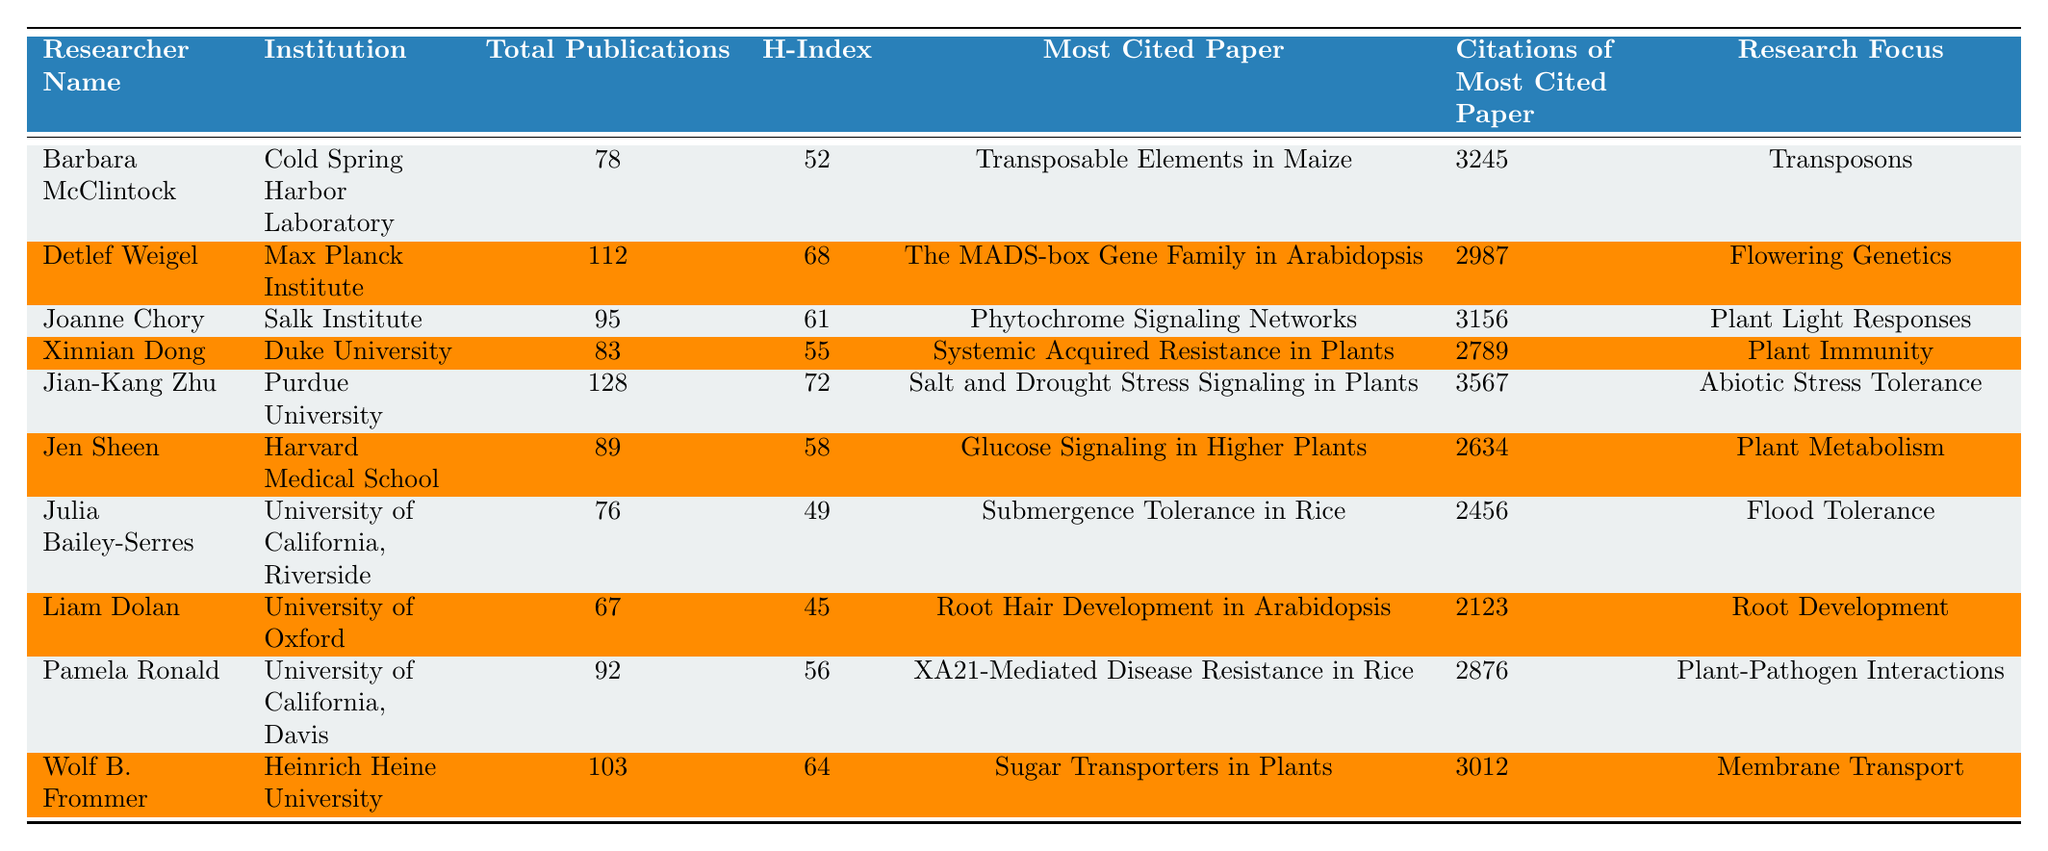What is the total number of publications by Jian-Kang Zhu? According to the table, Jian-Kang Zhu has 128 total publications listed in the "Total Publications" column.
Answer: 128 Which researcher has the highest H-Index? By scanning the H-Index values in the table, Jian-Kang Zhu has the highest H-Index at 72.
Answer: 72 How many citations does Barbara McClintock's most cited paper have? The table shows that Barbara McClintock's most cited paper has 3245 citations listed in the corresponding column.
Answer: 3245 Is Liam Dolan's research focus on Plant Immunity? The table indicates that Liam Dolan's research focus is on Root Development, not Plant Immunity. Therefore, the answer is false.
Answer: False What is the average number of total publications of the researchers listed in the table? The total number of publications for all researchers is 78 + 112 + 95 + 83 + 128 + 89 + 76 + 67 + 92 + 103 = 1021. There are 10 researchers, so the average is 1021/10 = 102.1.
Answer: 102.1 Which researcher has publications fewer than Liam Dolan? Liam Dolan has 67 publications. Looking at the table, both Julia Bailey-Serres (76) and Barbara McClintock (78) have more than 67 publications; however, no other researchers in the list have fewer than Liam Dolan. Therefore, the answer is Julia Bailey-Serres has fewer publications.
Answer: Julia Bailey-Serres Which researcher's most cited paper has the lowest citation count? From the table, Julia Bailey-Serres' most cited paper has the lowest citation count of 2456 among all the researchers listed.
Answer: Julia Bailey-Serres Who has a higher citation count for their most cited paper, Joanne Chory or Xinnian Dong? Joanne Chory’s most cited paper has 3156 citations while Xinnian Dong's most cited paper has 2789 citations. Thus, Joanne Chory has a higher citation count for her most cited paper.
Answer: Joanne Chory How many researchers have an H-Index greater than 60? By analyzing the H-Index column, five researchers have an H-Index greater than 60: Detlef Weigel (68), Jian-Kang Zhu (72), Joanne Chory (61), Wolf B. Frommer (64), and Pamela Ronald (56) does not inclusion, resulting in a total of four.
Answer: 4 If we focus on the research focus 'Plant Metabolism', how many total publications does Jen Sheen have? Looking at the "Research Focus" column, Jen Sheen's focus is on Plant Metabolism, and she has a total of 89 publications as indicated in the table.
Answer: 89 